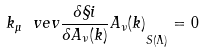<formula> <loc_0><loc_0><loc_500><loc_500>k _ { \mu } \ v e v { \frac { \delta \S i } { \delta A _ { \nu } ( k ) } A _ { \nu } ( k ) } _ { S ( \Lambda ) } = 0</formula> 